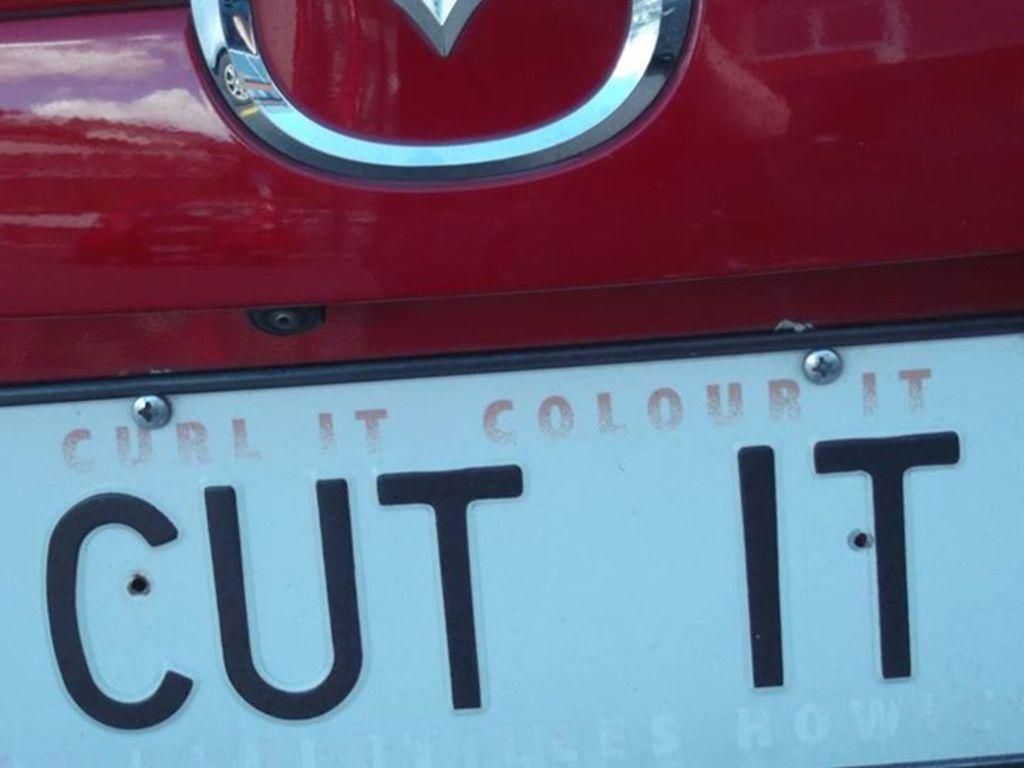<image>
Share a concise interpretation of the image provided. A vehicle's license plate consists of a stern order to "Cut It". 